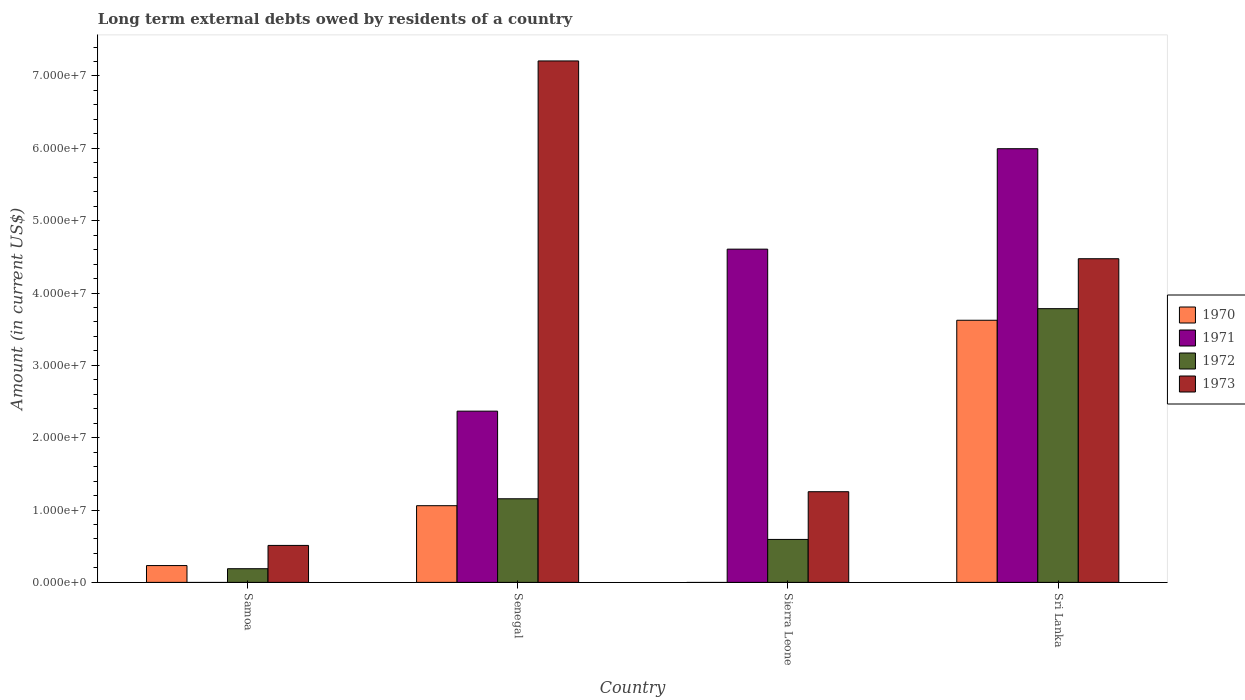Are the number of bars per tick equal to the number of legend labels?
Offer a very short reply. No. How many bars are there on the 2nd tick from the left?
Give a very brief answer. 4. How many bars are there on the 3rd tick from the right?
Ensure brevity in your answer.  4. What is the label of the 1st group of bars from the left?
Offer a terse response. Samoa. In how many cases, is the number of bars for a given country not equal to the number of legend labels?
Make the answer very short. 2. What is the amount of long-term external debts owed by residents in 1973 in Samoa?
Provide a succinct answer. 5.11e+06. Across all countries, what is the maximum amount of long-term external debts owed by residents in 1972?
Your response must be concise. 3.78e+07. Across all countries, what is the minimum amount of long-term external debts owed by residents in 1972?
Provide a short and direct response. 1.89e+06. In which country was the amount of long-term external debts owed by residents in 1973 maximum?
Make the answer very short. Senegal. What is the total amount of long-term external debts owed by residents in 1970 in the graph?
Your answer should be compact. 4.92e+07. What is the difference between the amount of long-term external debts owed by residents in 1973 in Senegal and that in Sierra Leone?
Offer a terse response. 5.95e+07. What is the difference between the amount of long-term external debts owed by residents in 1971 in Samoa and the amount of long-term external debts owed by residents in 1973 in Sierra Leone?
Make the answer very short. -1.25e+07. What is the average amount of long-term external debts owed by residents in 1973 per country?
Provide a short and direct response. 3.36e+07. What is the difference between the amount of long-term external debts owed by residents of/in 1973 and amount of long-term external debts owed by residents of/in 1971 in Sierra Leone?
Offer a very short reply. -3.35e+07. In how many countries, is the amount of long-term external debts owed by residents in 1971 greater than 6000000 US$?
Your answer should be compact. 3. What is the ratio of the amount of long-term external debts owed by residents in 1972 in Sierra Leone to that in Sri Lanka?
Offer a very short reply. 0.16. What is the difference between the highest and the second highest amount of long-term external debts owed by residents in 1971?
Offer a very short reply. 3.63e+07. What is the difference between the highest and the lowest amount of long-term external debts owed by residents in 1970?
Make the answer very short. 3.62e+07. Is the sum of the amount of long-term external debts owed by residents in 1971 in Senegal and Sri Lanka greater than the maximum amount of long-term external debts owed by residents in 1972 across all countries?
Your response must be concise. Yes. Is it the case that in every country, the sum of the amount of long-term external debts owed by residents in 1972 and amount of long-term external debts owed by residents in 1971 is greater than the amount of long-term external debts owed by residents in 1973?
Ensure brevity in your answer.  No. How many bars are there?
Your response must be concise. 14. Are all the bars in the graph horizontal?
Your response must be concise. No. How many countries are there in the graph?
Keep it short and to the point. 4. What is the difference between two consecutive major ticks on the Y-axis?
Your answer should be very brief. 1.00e+07. Are the values on the major ticks of Y-axis written in scientific E-notation?
Your response must be concise. Yes. Does the graph contain any zero values?
Ensure brevity in your answer.  Yes. Where does the legend appear in the graph?
Make the answer very short. Center right. What is the title of the graph?
Offer a very short reply. Long term external debts owed by residents of a country. Does "2014" appear as one of the legend labels in the graph?
Provide a short and direct response. No. What is the label or title of the X-axis?
Offer a terse response. Country. What is the label or title of the Y-axis?
Provide a short and direct response. Amount (in current US$). What is the Amount (in current US$) of 1970 in Samoa?
Keep it short and to the point. 2.32e+06. What is the Amount (in current US$) in 1972 in Samoa?
Provide a succinct answer. 1.89e+06. What is the Amount (in current US$) of 1973 in Samoa?
Give a very brief answer. 5.11e+06. What is the Amount (in current US$) of 1970 in Senegal?
Ensure brevity in your answer.  1.06e+07. What is the Amount (in current US$) in 1971 in Senegal?
Provide a succinct answer. 2.37e+07. What is the Amount (in current US$) in 1972 in Senegal?
Keep it short and to the point. 1.16e+07. What is the Amount (in current US$) in 1973 in Senegal?
Keep it short and to the point. 7.21e+07. What is the Amount (in current US$) in 1971 in Sierra Leone?
Provide a short and direct response. 4.61e+07. What is the Amount (in current US$) in 1972 in Sierra Leone?
Offer a very short reply. 5.94e+06. What is the Amount (in current US$) of 1973 in Sierra Leone?
Offer a terse response. 1.25e+07. What is the Amount (in current US$) of 1970 in Sri Lanka?
Provide a short and direct response. 3.62e+07. What is the Amount (in current US$) of 1971 in Sri Lanka?
Your response must be concise. 5.99e+07. What is the Amount (in current US$) of 1972 in Sri Lanka?
Provide a succinct answer. 3.78e+07. What is the Amount (in current US$) in 1973 in Sri Lanka?
Your answer should be compact. 4.47e+07. Across all countries, what is the maximum Amount (in current US$) of 1970?
Ensure brevity in your answer.  3.62e+07. Across all countries, what is the maximum Amount (in current US$) of 1971?
Offer a terse response. 5.99e+07. Across all countries, what is the maximum Amount (in current US$) of 1972?
Ensure brevity in your answer.  3.78e+07. Across all countries, what is the maximum Amount (in current US$) in 1973?
Offer a terse response. 7.21e+07. Across all countries, what is the minimum Amount (in current US$) of 1971?
Provide a succinct answer. 0. Across all countries, what is the minimum Amount (in current US$) of 1972?
Your answer should be very brief. 1.89e+06. Across all countries, what is the minimum Amount (in current US$) in 1973?
Make the answer very short. 5.11e+06. What is the total Amount (in current US$) in 1970 in the graph?
Your response must be concise. 4.92e+07. What is the total Amount (in current US$) of 1971 in the graph?
Your response must be concise. 1.30e+08. What is the total Amount (in current US$) of 1972 in the graph?
Ensure brevity in your answer.  5.72e+07. What is the total Amount (in current US$) in 1973 in the graph?
Your answer should be compact. 1.34e+08. What is the difference between the Amount (in current US$) in 1970 in Samoa and that in Senegal?
Ensure brevity in your answer.  -8.28e+06. What is the difference between the Amount (in current US$) of 1972 in Samoa and that in Senegal?
Your answer should be very brief. -9.67e+06. What is the difference between the Amount (in current US$) in 1973 in Samoa and that in Senegal?
Make the answer very short. -6.70e+07. What is the difference between the Amount (in current US$) in 1972 in Samoa and that in Sierra Leone?
Offer a very short reply. -4.05e+06. What is the difference between the Amount (in current US$) in 1973 in Samoa and that in Sierra Leone?
Make the answer very short. -7.42e+06. What is the difference between the Amount (in current US$) of 1970 in Samoa and that in Sri Lanka?
Offer a very short reply. -3.39e+07. What is the difference between the Amount (in current US$) of 1972 in Samoa and that in Sri Lanka?
Your response must be concise. -3.59e+07. What is the difference between the Amount (in current US$) of 1973 in Samoa and that in Sri Lanka?
Provide a short and direct response. -3.96e+07. What is the difference between the Amount (in current US$) of 1971 in Senegal and that in Sierra Leone?
Provide a succinct answer. -2.24e+07. What is the difference between the Amount (in current US$) of 1972 in Senegal and that in Sierra Leone?
Make the answer very short. 5.62e+06. What is the difference between the Amount (in current US$) in 1973 in Senegal and that in Sierra Leone?
Offer a terse response. 5.95e+07. What is the difference between the Amount (in current US$) of 1970 in Senegal and that in Sri Lanka?
Provide a short and direct response. -2.56e+07. What is the difference between the Amount (in current US$) of 1971 in Senegal and that in Sri Lanka?
Your answer should be very brief. -3.63e+07. What is the difference between the Amount (in current US$) in 1972 in Senegal and that in Sri Lanka?
Provide a succinct answer. -2.63e+07. What is the difference between the Amount (in current US$) of 1973 in Senegal and that in Sri Lanka?
Provide a succinct answer. 2.73e+07. What is the difference between the Amount (in current US$) of 1971 in Sierra Leone and that in Sri Lanka?
Provide a short and direct response. -1.39e+07. What is the difference between the Amount (in current US$) of 1972 in Sierra Leone and that in Sri Lanka?
Keep it short and to the point. -3.19e+07. What is the difference between the Amount (in current US$) in 1973 in Sierra Leone and that in Sri Lanka?
Make the answer very short. -3.22e+07. What is the difference between the Amount (in current US$) in 1970 in Samoa and the Amount (in current US$) in 1971 in Senegal?
Give a very brief answer. -2.13e+07. What is the difference between the Amount (in current US$) of 1970 in Samoa and the Amount (in current US$) of 1972 in Senegal?
Make the answer very short. -9.23e+06. What is the difference between the Amount (in current US$) in 1970 in Samoa and the Amount (in current US$) in 1973 in Senegal?
Your answer should be compact. -6.98e+07. What is the difference between the Amount (in current US$) of 1972 in Samoa and the Amount (in current US$) of 1973 in Senegal?
Offer a terse response. -7.02e+07. What is the difference between the Amount (in current US$) in 1970 in Samoa and the Amount (in current US$) in 1971 in Sierra Leone?
Make the answer very short. -4.37e+07. What is the difference between the Amount (in current US$) of 1970 in Samoa and the Amount (in current US$) of 1972 in Sierra Leone?
Your answer should be very brief. -3.61e+06. What is the difference between the Amount (in current US$) in 1970 in Samoa and the Amount (in current US$) in 1973 in Sierra Leone?
Provide a short and direct response. -1.02e+07. What is the difference between the Amount (in current US$) in 1972 in Samoa and the Amount (in current US$) in 1973 in Sierra Leone?
Offer a terse response. -1.06e+07. What is the difference between the Amount (in current US$) in 1970 in Samoa and the Amount (in current US$) in 1971 in Sri Lanka?
Ensure brevity in your answer.  -5.76e+07. What is the difference between the Amount (in current US$) in 1970 in Samoa and the Amount (in current US$) in 1972 in Sri Lanka?
Give a very brief answer. -3.55e+07. What is the difference between the Amount (in current US$) in 1970 in Samoa and the Amount (in current US$) in 1973 in Sri Lanka?
Your answer should be very brief. -4.24e+07. What is the difference between the Amount (in current US$) in 1972 in Samoa and the Amount (in current US$) in 1973 in Sri Lanka?
Your answer should be compact. -4.28e+07. What is the difference between the Amount (in current US$) in 1970 in Senegal and the Amount (in current US$) in 1971 in Sierra Leone?
Provide a succinct answer. -3.55e+07. What is the difference between the Amount (in current US$) of 1970 in Senegal and the Amount (in current US$) of 1972 in Sierra Leone?
Ensure brevity in your answer.  4.66e+06. What is the difference between the Amount (in current US$) of 1970 in Senegal and the Amount (in current US$) of 1973 in Sierra Leone?
Make the answer very short. -1.93e+06. What is the difference between the Amount (in current US$) in 1971 in Senegal and the Amount (in current US$) in 1972 in Sierra Leone?
Keep it short and to the point. 1.77e+07. What is the difference between the Amount (in current US$) of 1971 in Senegal and the Amount (in current US$) of 1973 in Sierra Leone?
Offer a terse response. 1.11e+07. What is the difference between the Amount (in current US$) of 1972 in Senegal and the Amount (in current US$) of 1973 in Sierra Leone?
Ensure brevity in your answer.  -9.76e+05. What is the difference between the Amount (in current US$) in 1970 in Senegal and the Amount (in current US$) in 1971 in Sri Lanka?
Make the answer very short. -4.93e+07. What is the difference between the Amount (in current US$) in 1970 in Senegal and the Amount (in current US$) in 1972 in Sri Lanka?
Ensure brevity in your answer.  -2.72e+07. What is the difference between the Amount (in current US$) of 1970 in Senegal and the Amount (in current US$) of 1973 in Sri Lanka?
Ensure brevity in your answer.  -3.41e+07. What is the difference between the Amount (in current US$) of 1971 in Senegal and the Amount (in current US$) of 1972 in Sri Lanka?
Provide a succinct answer. -1.42e+07. What is the difference between the Amount (in current US$) in 1971 in Senegal and the Amount (in current US$) in 1973 in Sri Lanka?
Make the answer very short. -2.11e+07. What is the difference between the Amount (in current US$) of 1972 in Senegal and the Amount (in current US$) of 1973 in Sri Lanka?
Your response must be concise. -3.32e+07. What is the difference between the Amount (in current US$) in 1971 in Sierra Leone and the Amount (in current US$) in 1972 in Sri Lanka?
Offer a very short reply. 8.23e+06. What is the difference between the Amount (in current US$) in 1971 in Sierra Leone and the Amount (in current US$) in 1973 in Sri Lanka?
Provide a short and direct response. 1.33e+06. What is the difference between the Amount (in current US$) of 1972 in Sierra Leone and the Amount (in current US$) of 1973 in Sri Lanka?
Ensure brevity in your answer.  -3.88e+07. What is the average Amount (in current US$) in 1970 per country?
Ensure brevity in your answer.  1.23e+07. What is the average Amount (in current US$) of 1971 per country?
Provide a short and direct response. 3.24e+07. What is the average Amount (in current US$) in 1972 per country?
Provide a short and direct response. 1.43e+07. What is the average Amount (in current US$) of 1973 per country?
Make the answer very short. 3.36e+07. What is the difference between the Amount (in current US$) of 1970 and Amount (in current US$) of 1972 in Samoa?
Your answer should be compact. 4.36e+05. What is the difference between the Amount (in current US$) of 1970 and Amount (in current US$) of 1973 in Samoa?
Your response must be concise. -2.79e+06. What is the difference between the Amount (in current US$) in 1972 and Amount (in current US$) in 1973 in Samoa?
Give a very brief answer. -3.22e+06. What is the difference between the Amount (in current US$) of 1970 and Amount (in current US$) of 1971 in Senegal?
Give a very brief answer. -1.31e+07. What is the difference between the Amount (in current US$) of 1970 and Amount (in current US$) of 1972 in Senegal?
Your answer should be compact. -9.56e+05. What is the difference between the Amount (in current US$) in 1970 and Amount (in current US$) in 1973 in Senegal?
Provide a succinct answer. -6.15e+07. What is the difference between the Amount (in current US$) of 1971 and Amount (in current US$) of 1972 in Senegal?
Make the answer very short. 1.21e+07. What is the difference between the Amount (in current US$) in 1971 and Amount (in current US$) in 1973 in Senegal?
Your answer should be compact. -4.84e+07. What is the difference between the Amount (in current US$) in 1972 and Amount (in current US$) in 1973 in Senegal?
Make the answer very short. -6.05e+07. What is the difference between the Amount (in current US$) of 1971 and Amount (in current US$) of 1972 in Sierra Leone?
Your response must be concise. 4.01e+07. What is the difference between the Amount (in current US$) in 1971 and Amount (in current US$) in 1973 in Sierra Leone?
Offer a very short reply. 3.35e+07. What is the difference between the Amount (in current US$) of 1972 and Amount (in current US$) of 1973 in Sierra Leone?
Your response must be concise. -6.60e+06. What is the difference between the Amount (in current US$) in 1970 and Amount (in current US$) in 1971 in Sri Lanka?
Make the answer very short. -2.37e+07. What is the difference between the Amount (in current US$) of 1970 and Amount (in current US$) of 1972 in Sri Lanka?
Make the answer very short. -1.60e+06. What is the difference between the Amount (in current US$) of 1970 and Amount (in current US$) of 1973 in Sri Lanka?
Your response must be concise. -8.50e+06. What is the difference between the Amount (in current US$) in 1971 and Amount (in current US$) in 1972 in Sri Lanka?
Your response must be concise. 2.21e+07. What is the difference between the Amount (in current US$) of 1971 and Amount (in current US$) of 1973 in Sri Lanka?
Keep it short and to the point. 1.52e+07. What is the difference between the Amount (in current US$) in 1972 and Amount (in current US$) in 1973 in Sri Lanka?
Offer a very short reply. -6.90e+06. What is the ratio of the Amount (in current US$) of 1970 in Samoa to that in Senegal?
Give a very brief answer. 0.22. What is the ratio of the Amount (in current US$) of 1972 in Samoa to that in Senegal?
Your answer should be compact. 0.16. What is the ratio of the Amount (in current US$) of 1973 in Samoa to that in Senegal?
Give a very brief answer. 0.07. What is the ratio of the Amount (in current US$) in 1972 in Samoa to that in Sierra Leone?
Provide a short and direct response. 0.32. What is the ratio of the Amount (in current US$) in 1973 in Samoa to that in Sierra Leone?
Give a very brief answer. 0.41. What is the ratio of the Amount (in current US$) of 1970 in Samoa to that in Sri Lanka?
Ensure brevity in your answer.  0.06. What is the ratio of the Amount (in current US$) of 1972 in Samoa to that in Sri Lanka?
Give a very brief answer. 0.05. What is the ratio of the Amount (in current US$) in 1973 in Samoa to that in Sri Lanka?
Your answer should be very brief. 0.11. What is the ratio of the Amount (in current US$) in 1971 in Senegal to that in Sierra Leone?
Ensure brevity in your answer.  0.51. What is the ratio of the Amount (in current US$) of 1972 in Senegal to that in Sierra Leone?
Your answer should be compact. 1.95. What is the ratio of the Amount (in current US$) of 1973 in Senegal to that in Sierra Leone?
Your answer should be compact. 5.75. What is the ratio of the Amount (in current US$) of 1970 in Senegal to that in Sri Lanka?
Keep it short and to the point. 0.29. What is the ratio of the Amount (in current US$) of 1971 in Senegal to that in Sri Lanka?
Keep it short and to the point. 0.39. What is the ratio of the Amount (in current US$) of 1972 in Senegal to that in Sri Lanka?
Your answer should be compact. 0.31. What is the ratio of the Amount (in current US$) of 1973 in Senegal to that in Sri Lanka?
Keep it short and to the point. 1.61. What is the ratio of the Amount (in current US$) of 1971 in Sierra Leone to that in Sri Lanka?
Make the answer very short. 0.77. What is the ratio of the Amount (in current US$) of 1972 in Sierra Leone to that in Sri Lanka?
Provide a short and direct response. 0.16. What is the ratio of the Amount (in current US$) of 1973 in Sierra Leone to that in Sri Lanka?
Offer a terse response. 0.28. What is the difference between the highest and the second highest Amount (in current US$) of 1970?
Your answer should be compact. 2.56e+07. What is the difference between the highest and the second highest Amount (in current US$) in 1971?
Keep it short and to the point. 1.39e+07. What is the difference between the highest and the second highest Amount (in current US$) of 1972?
Your answer should be very brief. 2.63e+07. What is the difference between the highest and the second highest Amount (in current US$) in 1973?
Your answer should be very brief. 2.73e+07. What is the difference between the highest and the lowest Amount (in current US$) in 1970?
Give a very brief answer. 3.62e+07. What is the difference between the highest and the lowest Amount (in current US$) of 1971?
Give a very brief answer. 5.99e+07. What is the difference between the highest and the lowest Amount (in current US$) in 1972?
Offer a very short reply. 3.59e+07. What is the difference between the highest and the lowest Amount (in current US$) in 1973?
Give a very brief answer. 6.70e+07. 